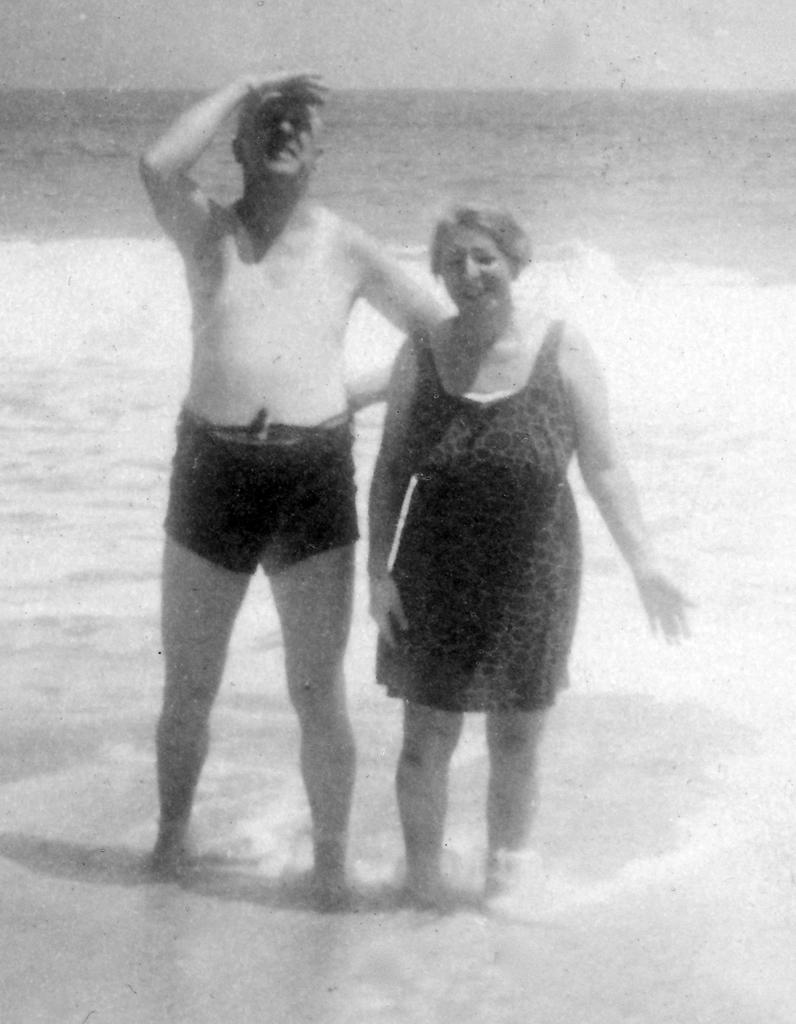What is the color scheme of the image? The image is black and white. What are the two persons in the image doing? The two persons are standing in the water. What can be seen in the background of the image? There is a sky visible in the background of the image. What flavor of ice cream is being held by the person on the left in the image? There is no ice cream or any indication of flavors in the image. 